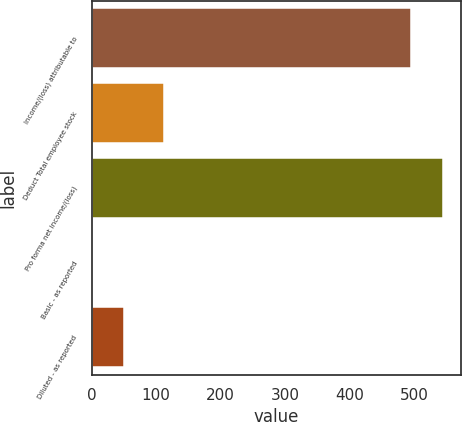Convert chart. <chart><loc_0><loc_0><loc_500><loc_500><bar_chart><fcel>Income/(loss) attributable to<fcel>Deduct Total employee stock<fcel>Pro forma net income/(loss)<fcel>Basic - as reported<fcel>Diluted - as reported<nl><fcel>495<fcel>112<fcel>544.47<fcel>0.27<fcel>49.74<nl></chart> 